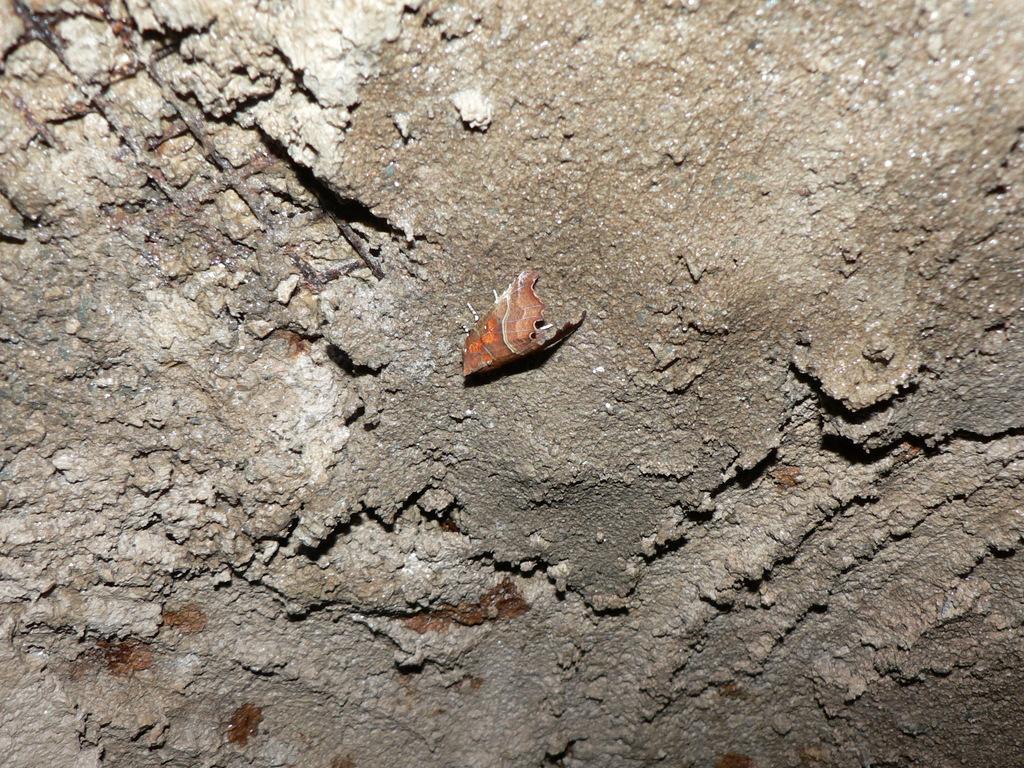In one or two sentences, can you explain what this image depicts? In this image there is a concrete mixture and there are a few iron rods. In the middle of the image there is a fly on the concrete mixture. 